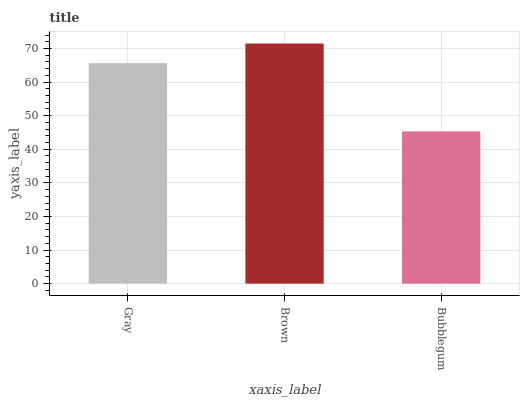Is Bubblegum the minimum?
Answer yes or no. Yes. Is Brown the maximum?
Answer yes or no. Yes. Is Brown the minimum?
Answer yes or no. No. Is Bubblegum the maximum?
Answer yes or no. No. Is Brown greater than Bubblegum?
Answer yes or no. Yes. Is Bubblegum less than Brown?
Answer yes or no. Yes. Is Bubblegum greater than Brown?
Answer yes or no. No. Is Brown less than Bubblegum?
Answer yes or no. No. Is Gray the high median?
Answer yes or no. Yes. Is Gray the low median?
Answer yes or no. Yes. Is Brown the high median?
Answer yes or no. No. Is Brown the low median?
Answer yes or no. No. 